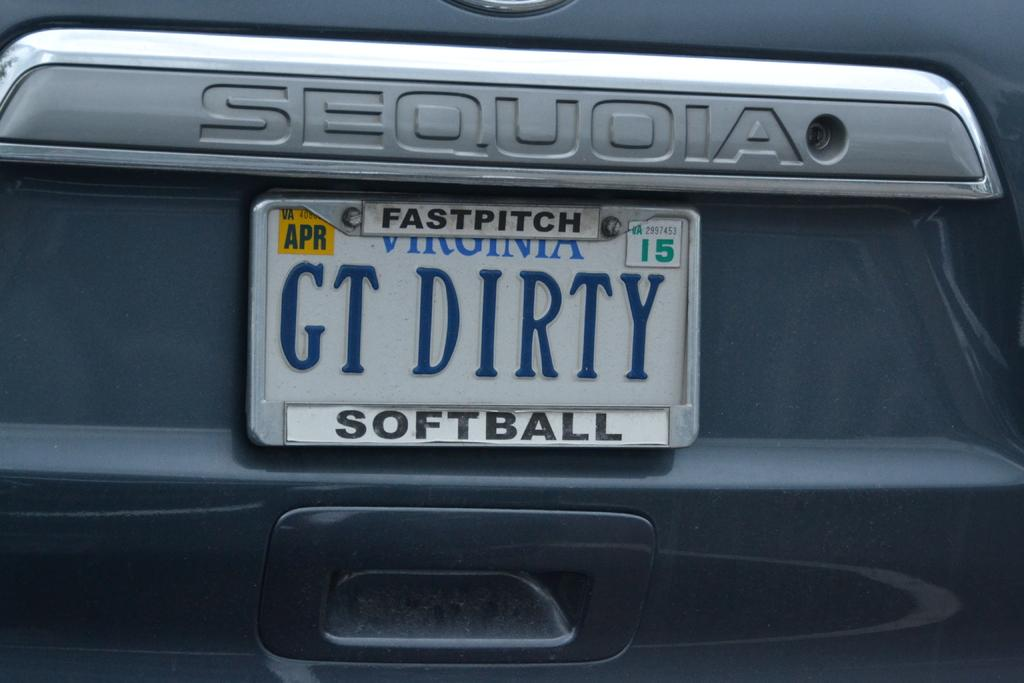<image>
Summarize the visual content of the image. A Sequoia branded behicle has a Virginia state license plate that reads GT dirty. 